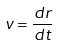Convert formula to latex. <formula><loc_0><loc_0><loc_500><loc_500>v = \frac { d r } { d t }</formula> 